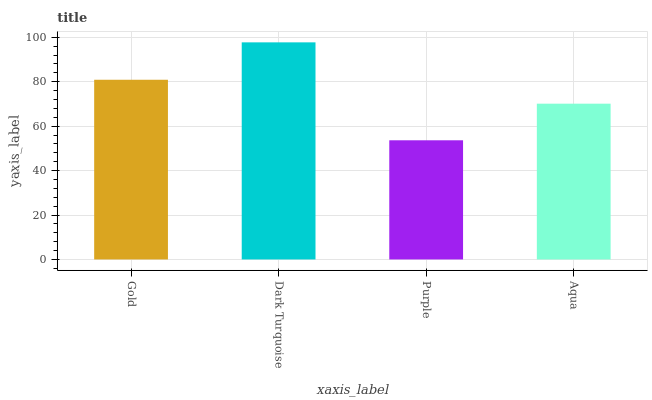Is Purple the minimum?
Answer yes or no. Yes. Is Dark Turquoise the maximum?
Answer yes or no. Yes. Is Dark Turquoise the minimum?
Answer yes or no. No. Is Purple the maximum?
Answer yes or no. No. Is Dark Turquoise greater than Purple?
Answer yes or no. Yes. Is Purple less than Dark Turquoise?
Answer yes or no. Yes. Is Purple greater than Dark Turquoise?
Answer yes or no. No. Is Dark Turquoise less than Purple?
Answer yes or no. No. Is Gold the high median?
Answer yes or no. Yes. Is Aqua the low median?
Answer yes or no. Yes. Is Purple the high median?
Answer yes or no. No. Is Purple the low median?
Answer yes or no. No. 